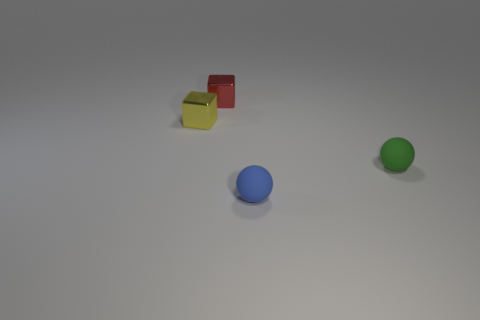Does the green thing have the same material as the tiny blue ball?
Keep it short and to the point. Yes. Is the number of small blue balls left of the blue matte ball the same as the number of green objects?
Offer a terse response. No. What number of cubes have the same material as the green sphere?
Your answer should be very brief. 0. Are there fewer small yellow metal cubes than tiny matte cylinders?
Offer a very short reply. No. There is a cube on the left side of the metallic block behind the small yellow metallic object; how many tiny things are behind it?
Your answer should be very brief. 1. There is a small yellow shiny cube; what number of small rubber spheres are right of it?
Make the answer very short. 2. There is another tiny object that is the same shape as the small blue rubber object; what color is it?
Keep it short and to the point. Green. What is the material of the thing that is in front of the tiny red block and behind the green thing?
Provide a short and direct response. Metal. There is a metal cube in front of the red cube; does it have the same size as the green matte object?
Offer a very short reply. Yes. What is the material of the small yellow cube?
Your answer should be very brief. Metal. 